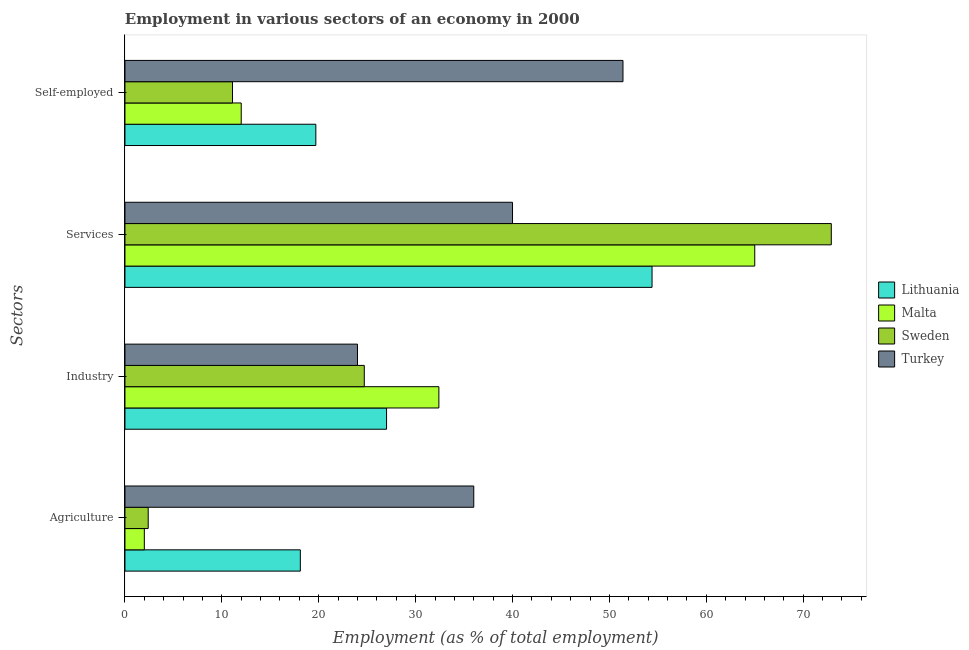How many groups of bars are there?
Provide a short and direct response. 4. Are the number of bars per tick equal to the number of legend labels?
Provide a short and direct response. Yes. Are the number of bars on each tick of the Y-axis equal?
Ensure brevity in your answer.  Yes. What is the label of the 2nd group of bars from the top?
Offer a very short reply. Services. What is the percentage of workers in agriculture in Lithuania?
Offer a terse response. 18.1. Across all countries, what is the maximum percentage of self employed workers?
Provide a short and direct response. 51.4. Across all countries, what is the minimum percentage of self employed workers?
Give a very brief answer. 11.1. In which country was the percentage of workers in agriculture maximum?
Your answer should be compact. Turkey. In which country was the percentage of workers in industry minimum?
Provide a succinct answer. Turkey. What is the total percentage of workers in agriculture in the graph?
Give a very brief answer. 58.5. What is the difference between the percentage of workers in industry in Sweden and the percentage of self employed workers in Turkey?
Keep it short and to the point. -26.7. What is the average percentage of workers in agriculture per country?
Provide a short and direct response. 14.63. What is the difference between the percentage of workers in agriculture and percentage of workers in industry in Malta?
Your answer should be compact. -30.4. What is the ratio of the percentage of workers in agriculture in Sweden to that in Turkey?
Offer a very short reply. 0.07. Is the percentage of workers in industry in Lithuania less than that in Malta?
Your answer should be compact. Yes. Is the difference between the percentage of workers in industry in Malta and Turkey greater than the difference between the percentage of self employed workers in Malta and Turkey?
Your response must be concise. Yes. What is the difference between the highest and the second highest percentage of self employed workers?
Your answer should be compact. 31.7. What is the difference between the highest and the lowest percentage of workers in industry?
Give a very brief answer. 8.4. In how many countries, is the percentage of workers in industry greater than the average percentage of workers in industry taken over all countries?
Keep it short and to the point. 1. Is it the case that in every country, the sum of the percentage of self employed workers and percentage of workers in agriculture is greater than the sum of percentage of workers in industry and percentage of workers in services?
Your answer should be very brief. No. What does the 3rd bar from the top in Services represents?
Keep it short and to the point. Malta. Is it the case that in every country, the sum of the percentage of workers in agriculture and percentage of workers in industry is greater than the percentage of workers in services?
Ensure brevity in your answer.  No. How many countries are there in the graph?
Provide a succinct answer. 4. What is the difference between two consecutive major ticks on the X-axis?
Provide a succinct answer. 10. Does the graph contain any zero values?
Your answer should be very brief. No. Does the graph contain grids?
Offer a very short reply. No. Where does the legend appear in the graph?
Provide a short and direct response. Center right. How many legend labels are there?
Keep it short and to the point. 4. How are the legend labels stacked?
Provide a succinct answer. Vertical. What is the title of the graph?
Offer a very short reply. Employment in various sectors of an economy in 2000. What is the label or title of the X-axis?
Give a very brief answer. Employment (as % of total employment). What is the label or title of the Y-axis?
Your answer should be very brief. Sectors. What is the Employment (as % of total employment) in Lithuania in Agriculture?
Offer a very short reply. 18.1. What is the Employment (as % of total employment) in Malta in Agriculture?
Make the answer very short. 2. What is the Employment (as % of total employment) in Sweden in Agriculture?
Provide a succinct answer. 2.4. What is the Employment (as % of total employment) in Turkey in Agriculture?
Your response must be concise. 36. What is the Employment (as % of total employment) of Malta in Industry?
Your answer should be very brief. 32.4. What is the Employment (as % of total employment) of Sweden in Industry?
Your answer should be compact. 24.7. What is the Employment (as % of total employment) of Turkey in Industry?
Your response must be concise. 24. What is the Employment (as % of total employment) of Lithuania in Services?
Provide a short and direct response. 54.4. What is the Employment (as % of total employment) in Malta in Services?
Make the answer very short. 65. What is the Employment (as % of total employment) of Sweden in Services?
Your answer should be very brief. 72.9. What is the Employment (as % of total employment) in Turkey in Services?
Your response must be concise. 40. What is the Employment (as % of total employment) in Lithuania in Self-employed?
Offer a very short reply. 19.7. What is the Employment (as % of total employment) in Sweden in Self-employed?
Your response must be concise. 11.1. What is the Employment (as % of total employment) of Turkey in Self-employed?
Your answer should be compact. 51.4. Across all Sectors, what is the maximum Employment (as % of total employment) in Lithuania?
Offer a terse response. 54.4. Across all Sectors, what is the maximum Employment (as % of total employment) in Malta?
Give a very brief answer. 65. Across all Sectors, what is the maximum Employment (as % of total employment) in Sweden?
Keep it short and to the point. 72.9. Across all Sectors, what is the maximum Employment (as % of total employment) of Turkey?
Provide a succinct answer. 51.4. Across all Sectors, what is the minimum Employment (as % of total employment) of Lithuania?
Provide a succinct answer. 18.1. Across all Sectors, what is the minimum Employment (as % of total employment) in Sweden?
Offer a very short reply. 2.4. What is the total Employment (as % of total employment) of Lithuania in the graph?
Your answer should be compact. 119.2. What is the total Employment (as % of total employment) of Malta in the graph?
Provide a succinct answer. 111.4. What is the total Employment (as % of total employment) in Sweden in the graph?
Provide a short and direct response. 111.1. What is the total Employment (as % of total employment) of Turkey in the graph?
Offer a very short reply. 151.4. What is the difference between the Employment (as % of total employment) of Malta in Agriculture and that in Industry?
Give a very brief answer. -30.4. What is the difference between the Employment (as % of total employment) of Sweden in Agriculture and that in Industry?
Provide a succinct answer. -22.3. What is the difference between the Employment (as % of total employment) in Lithuania in Agriculture and that in Services?
Provide a short and direct response. -36.3. What is the difference between the Employment (as % of total employment) in Malta in Agriculture and that in Services?
Ensure brevity in your answer.  -63. What is the difference between the Employment (as % of total employment) in Sweden in Agriculture and that in Services?
Offer a terse response. -70.5. What is the difference between the Employment (as % of total employment) of Turkey in Agriculture and that in Services?
Give a very brief answer. -4. What is the difference between the Employment (as % of total employment) in Lithuania in Agriculture and that in Self-employed?
Make the answer very short. -1.6. What is the difference between the Employment (as % of total employment) in Turkey in Agriculture and that in Self-employed?
Your answer should be very brief. -15.4. What is the difference between the Employment (as % of total employment) in Lithuania in Industry and that in Services?
Ensure brevity in your answer.  -27.4. What is the difference between the Employment (as % of total employment) of Malta in Industry and that in Services?
Provide a short and direct response. -32.6. What is the difference between the Employment (as % of total employment) of Sweden in Industry and that in Services?
Your response must be concise. -48.2. What is the difference between the Employment (as % of total employment) of Lithuania in Industry and that in Self-employed?
Offer a very short reply. 7.3. What is the difference between the Employment (as % of total employment) of Malta in Industry and that in Self-employed?
Provide a succinct answer. 20.4. What is the difference between the Employment (as % of total employment) in Sweden in Industry and that in Self-employed?
Keep it short and to the point. 13.6. What is the difference between the Employment (as % of total employment) of Turkey in Industry and that in Self-employed?
Your answer should be very brief. -27.4. What is the difference between the Employment (as % of total employment) in Lithuania in Services and that in Self-employed?
Make the answer very short. 34.7. What is the difference between the Employment (as % of total employment) in Malta in Services and that in Self-employed?
Provide a succinct answer. 53. What is the difference between the Employment (as % of total employment) of Sweden in Services and that in Self-employed?
Your response must be concise. 61.8. What is the difference between the Employment (as % of total employment) of Turkey in Services and that in Self-employed?
Make the answer very short. -11.4. What is the difference between the Employment (as % of total employment) in Lithuania in Agriculture and the Employment (as % of total employment) in Malta in Industry?
Give a very brief answer. -14.3. What is the difference between the Employment (as % of total employment) in Lithuania in Agriculture and the Employment (as % of total employment) in Sweden in Industry?
Your response must be concise. -6.6. What is the difference between the Employment (as % of total employment) in Lithuania in Agriculture and the Employment (as % of total employment) in Turkey in Industry?
Keep it short and to the point. -5.9. What is the difference between the Employment (as % of total employment) in Malta in Agriculture and the Employment (as % of total employment) in Sweden in Industry?
Make the answer very short. -22.7. What is the difference between the Employment (as % of total employment) of Malta in Agriculture and the Employment (as % of total employment) of Turkey in Industry?
Give a very brief answer. -22. What is the difference between the Employment (as % of total employment) in Sweden in Agriculture and the Employment (as % of total employment) in Turkey in Industry?
Give a very brief answer. -21.6. What is the difference between the Employment (as % of total employment) of Lithuania in Agriculture and the Employment (as % of total employment) of Malta in Services?
Keep it short and to the point. -46.9. What is the difference between the Employment (as % of total employment) in Lithuania in Agriculture and the Employment (as % of total employment) in Sweden in Services?
Ensure brevity in your answer.  -54.8. What is the difference between the Employment (as % of total employment) of Lithuania in Agriculture and the Employment (as % of total employment) of Turkey in Services?
Offer a very short reply. -21.9. What is the difference between the Employment (as % of total employment) in Malta in Agriculture and the Employment (as % of total employment) in Sweden in Services?
Keep it short and to the point. -70.9. What is the difference between the Employment (as % of total employment) in Malta in Agriculture and the Employment (as % of total employment) in Turkey in Services?
Your response must be concise. -38. What is the difference between the Employment (as % of total employment) in Sweden in Agriculture and the Employment (as % of total employment) in Turkey in Services?
Make the answer very short. -37.6. What is the difference between the Employment (as % of total employment) in Lithuania in Agriculture and the Employment (as % of total employment) in Sweden in Self-employed?
Offer a terse response. 7. What is the difference between the Employment (as % of total employment) in Lithuania in Agriculture and the Employment (as % of total employment) in Turkey in Self-employed?
Your response must be concise. -33.3. What is the difference between the Employment (as % of total employment) in Malta in Agriculture and the Employment (as % of total employment) in Turkey in Self-employed?
Offer a very short reply. -49.4. What is the difference between the Employment (as % of total employment) in Sweden in Agriculture and the Employment (as % of total employment) in Turkey in Self-employed?
Your answer should be compact. -49. What is the difference between the Employment (as % of total employment) of Lithuania in Industry and the Employment (as % of total employment) of Malta in Services?
Offer a very short reply. -38. What is the difference between the Employment (as % of total employment) of Lithuania in Industry and the Employment (as % of total employment) of Sweden in Services?
Keep it short and to the point. -45.9. What is the difference between the Employment (as % of total employment) in Lithuania in Industry and the Employment (as % of total employment) in Turkey in Services?
Offer a terse response. -13. What is the difference between the Employment (as % of total employment) in Malta in Industry and the Employment (as % of total employment) in Sweden in Services?
Provide a short and direct response. -40.5. What is the difference between the Employment (as % of total employment) in Malta in Industry and the Employment (as % of total employment) in Turkey in Services?
Make the answer very short. -7.6. What is the difference between the Employment (as % of total employment) of Sweden in Industry and the Employment (as % of total employment) of Turkey in Services?
Provide a succinct answer. -15.3. What is the difference between the Employment (as % of total employment) of Lithuania in Industry and the Employment (as % of total employment) of Malta in Self-employed?
Make the answer very short. 15. What is the difference between the Employment (as % of total employment) in Lithuania in Industry and the Employment (as % of total employment) in Turkey in Self-employed?
Offer a terse response. -24.4. What is the difference between the Employment (as % of total employment) in Malta in Industry and the Employment (as % of total employment) in Sweden in Self-employed?
Your answer should be compact. 21.3. What is the difference between the Employment (as % of total employment) of Malta in Industry and the Employment (as % of total employment) of Turkey in Self-employed?
Offer a very short reply. -19. What is the difference between the Employment (as % of total employment) of Sweden in Industry and the Employment (as % of total employment) of Turkey in Self-employed?
Ensure brevity in your answer.  -26.7. What is the difference between the Employment (as % of total employment) in Lithuania in Services and the Employment (as % of total employment) in Malta in Self-employed?
Provide a succinct answer. 42.4. What is the difference between the Employment (as % of total employment) of Lithuania in Services and the Employment (as % of total employment) of Sweden in Self-employed?
Ensure brevity in your answer.  43.3. What is the difference between the Employment (as % of total employment) in Malta in Services and the Employment (as % of total employment) in Sweden in Self-employed?
Your answer should be very brief. 53.9. What is the difference between the Employment (as % of total employment) in Malta in Services and the Employment (as % of total employment) in Turkey in Self-employed?
Provide a short and direct response. 13.6. What is the average Employment (as % of total employment) in Lithuania per Sectors?
Offer a terse response. 29.8. What is the average Employment (as % of total employment) in Malta per Sectors?
Offer a very short reply. 27.85. What is the average Employment (as % of total employment) of Sweden per Sectors?
Make the answer very short. 27.77. What is the average Employment (as % of total employment) of Turkey per Sectors?
Make the answer very short. 37.85. What is the difference between the Employment (as % of total employment) in Lithuania and Employment (as % of total employment) in Sweden in Agriculture?
Offer a very short reply. 15.7. What is the difference between the Employment (as % of total employment) of Lithuania and Employment (as % of total employment) of Turkey in Agriculture?
Your answer should be compact. -17.9. What is the difference between the Employment (as % of total employment) of Malta and Employment (as % of total employment) of Turkey in Agriculture?
Provide a succinct answer. -34. What is the difference between the Employment (as % of total employment) in Sweden and Employment (as % of total employment) in Turkey in Agriculture?
Your response must be concise. -33.6. What is the difference between the Employment (as % of total employment) of Lithuania and Employment (as % of total employment) of Malta in Industry?
Give a very brief answer. -5.4. What is the difference between the Employment (as % of total employment) in Lithuania and Employment (as % of total employment) in Sweden in Industry?
Give a very brief answer. 2.3. What is the difference between the Employment (as % of total employment) of Lithuania and Employment (as % of total employment) of Sweden in Services?
Your answer should be compact. -18.5. What is the difference between the Employment (as % of total employment) in Lithuania and Employment (as % of total employment) in Turkey in Services?
Make the answer very short. 14.4. What is the difference between the Employment (as % of total employment) of Malta and Employment (as % of total employment) of Turkey in Services?
Give a very brief answer. 25. What is the difference between the Employment (as % of total employment) of Sweden and Employment (as % of total employment) of Turkey in Services?
Offer a very short reply. 32.9. What is the difference between the Employment (as % of total employment) in Lithuania and Employment (as % of total employment) in Turkey in Self-employed?
Make the answer very short. -31.7. What is the difference between the Employment (as % of total employment) in Malta and Employment (as % of total employment) in Turkey in Self-employed?
Make the answer very short. -39.4. What is the difference between the Employment (as % of total employment) in Sweden and Employment (as % of total employment) in Turkey in Self-employed?
Offer a very short reply. -40.3. What is the ratio of the Employment (as % of total employment) in Lithuania in Agriculture to that in Industry?
Provide a succinct answer. 0.67. What is the ratio of the Employment (as % of total employment) in Malta in Agriculture to that in Industry?
Provide a short and direct response. 0.06. What is the ratio of the Employment (as % of total employment) of Sweden in Agriculture to that in Industry?
Provide a short and direct response. 0.1. What is the ratio of the Employment (as % of total employment) in Turkey in Agriculture to that in Industry?
Keep it short and to the point. 1.5. What is the ratio of the Employment (as % of total employment) in Lithuania in Agriculture to that in Services?
Offer a very short reply. 0.33. What is the ratio of the Employment (as % of total employment) of Malta in Agriculture to that in Services?
Provide a short and direct response. 0.03. What is the ratio of the Employment (as % of total employment) in Sweden in Agriculture to that in Services?
Offer a very short reply. 0.03. What is the ratio of the Employment (as % of total employment) in Lithuania in Agriculture to that in Self-employed?
Offer a terse response. 0.92. What is the ratio of the Employment (as % of total employment) of Malta in Agriculture to that in Self-employed?
Offer a very short reply. 0.17. What is the ratio of the Employment (as % of total employment) in Sweden in Agriculture to that in Self-employed?
Provide a succinct answer. 0.22. What is the ratio of the Employment (as % of total employment) in Turkey in Agriculture to that in Self-employed?
Keep it short and to the point. 0.7. What is the ratio of the Employment (as % of total employment) in Lithuania in Industry to that in Services?
Offer a terse response. 0.5. What is the ratio of the Employment (as % of total employment) of Malta in Industry to that in Services?
Your answer should be very brief. 0.5. What is the ratio of the Employment (as % of total employment) in Sweden in Industry to that in Services?
Your answer should be compact. 0.34. What is the ratio of the Employment (as % of total employment) of Lithuania in Industry to that in Self-employed?
Offer a terse response. 1.37. What is the ratio of the Employment (as % of total employment) of Malta in Industry to that in Self-employed?
Give a very brief answer. 2.7. What is the ratio of the Employment (as % of total employment) in Sweden in Industry to that in Self-employed?
Offer a terse response. 2.23. What is the ratio of the Employment (as % of total employment) in Turkey in Industry to that in Self-employed?
Offer a very short reply. 0.47. What is the ratio of the Employment (as % of total employment) in Lithuania in Services to that in Self-employed?
Give a very brief answer. 2.76. What is the ratio of the Employment (as % of total employment) of Malta in Services to that in Self-employed?
Ensure brevity in your answer.  5.42. What is the ratio of the Employment (as % of total employment) of Sweden in Services to that in Self-employed?
Make the answer very short. 6.57. What is the ratio of the Employment (as % of total employment) in Turkey in Services to that in Self-employed?
Provide a succinct answer. 0.78. What is the difference between the highest and the second highest Employment (as % of total employment) of Lithuania?
Your answer should be very brief. 27.4. What is the difference between the highest and the second highest Employment (as % of total employment) of Malta?
Offer a very short reply. 32.6. What is the difference between the highest and the second highest Employment (as % of total employment) of Sweden?
Provide a short and direct response. 48.2. What is the difference between the highest and the lowest Employment (as % of total employment) of Lithuania?
Provide a short and direct response. 36.3. What is the difference between the highest and the lowest Employment (as % of total employment) of Sweden?
Your response must be concise. 70.5. What is the difference between the highest and the lowest Employment (as % of total employment) of Turkey?
Give a very brief answer. 27.4. 